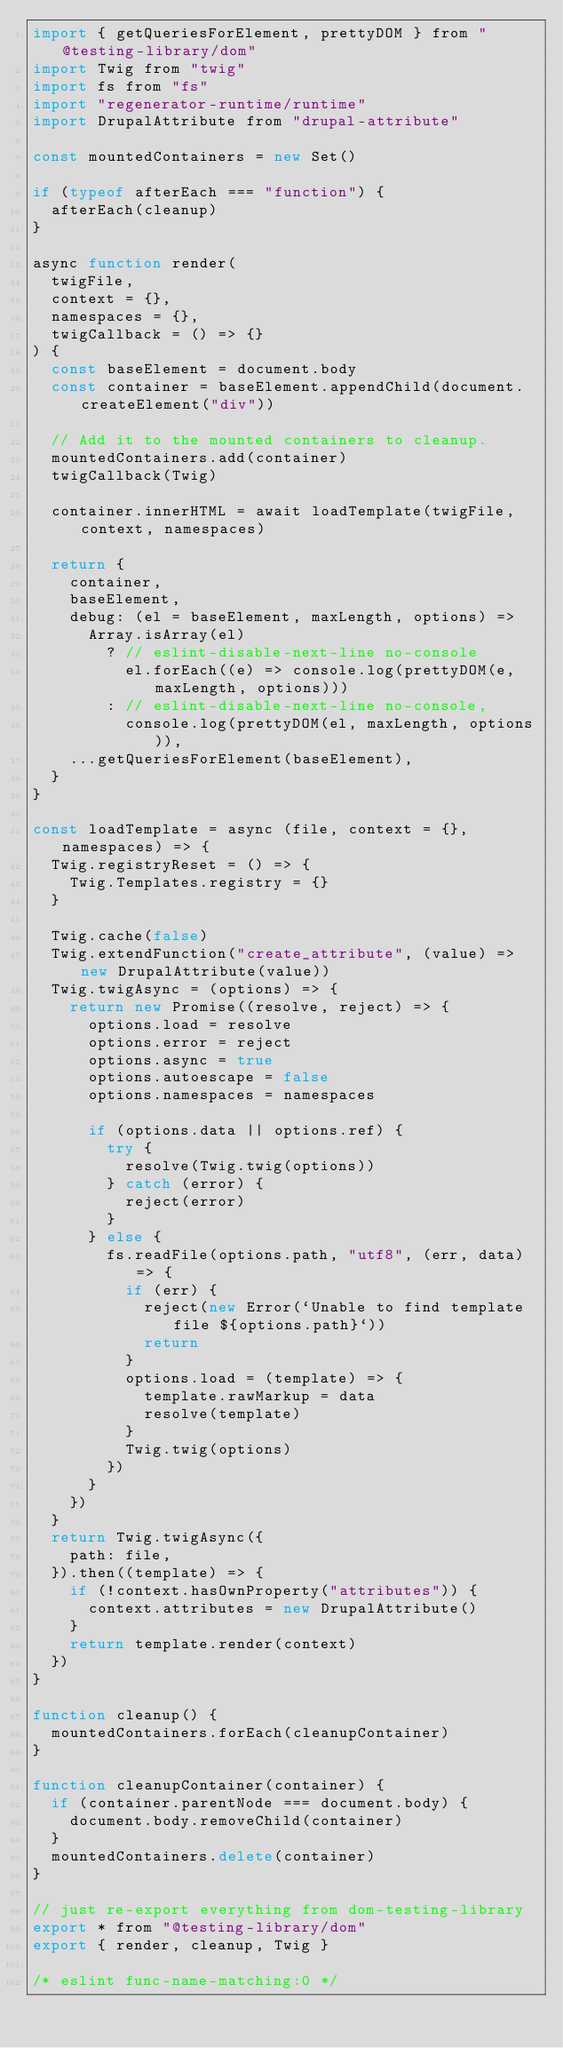<code> <loc_0><loc_0><loc_500><loc_500><_JavaScript_>import { getQueriesForElement, prettyDOM } from "@testing-library/dom"
import Twig from "twig"
import fs from "fs"
import "regenerator-runtime/runtime"
import DrupalAttribute from "drupal-attribute"

const mountedContainers = new Set()

if (typeof afterEach === "function") {
  afterEach(cleanup)
}

async function render(
  twigFile,
  context = {},
  namespaces = {},
  twigCallback = () => {}
) {
  const baseElement = document.body
  const container = baseElement.appendChild(document.createElement("div"))

  // Add it to the mounted containers to cleanup.
  mountedContainers.add(container)
  twigCallback(Twig)

  container.innerHTML = await loadTemplate(twigFile, context, namespaces)

  return {
    container,
    baseElement,
    debug: (el = baseElement, maxLength, options) =>
      Array.isArray(el)
        ? // eslint-disable-next-line no-console
          el.forEach((e) => console.log(prettyDOM(e, maxLength, options)))
        : // eslint-disable-next-line no-console,
          console.log(prettyDOM(el, maxLength, options)),
    ...getQueriesForElement(baseElement),
  }
}

const loadTemplate = async (file, context = {}, namespaces) => {
  Twig.registryReset = () => {
    Twig.Templates.registry = {}
  }

  Twig.cache(false)
  Twig.extendFunction("create_attribute", (value) => new DrupalAttribute(value))
  Twig.twigAsync = (options) => {
    return new Promise((resolve, reject) => {
      options.load = resolve
      options.error = reject
      options.async = true
      options.autoescape = false
      options.namespaces = namespaces

      if (options.data || options.ref) {
        try {
          resolve(Twig.twig(options))
        } catch (error) {
          reject(error)
        }
      } else {
        fs.readFile(options.path, "utf8", (err, data) => {
          if (err) {
            reject(new Error(`Unable to find template file ${options.path}`))
            return
          }
          options.load = (template) => {
            template.rawMarkup = data
            resolve(template)
          }
          Twig.twig(options)
        })
      }
    })
  }
  return Twig.twigAsync({
    path: file,
  }).then((template) => {
    if (!context.hasOwnProperty("attributes")) {
      context.attributes = new DrupalAttribute()
    }
    return template.render(context)
  })
}

function cleanup() {
  mountedContainers.forEach(cleanupContainer)
}

function cleanupContainer(container) {
  if (container.parentNode === document.body) {
    document.body.removeChild(container)
  }
  mountedContainers.delete(container)
}

// just re-export everything from dom-testing-library
export * from "@testing-library/dom"
export { render, cleanup, Twig }

/* eslint func-name-matching:0 */
</code> 